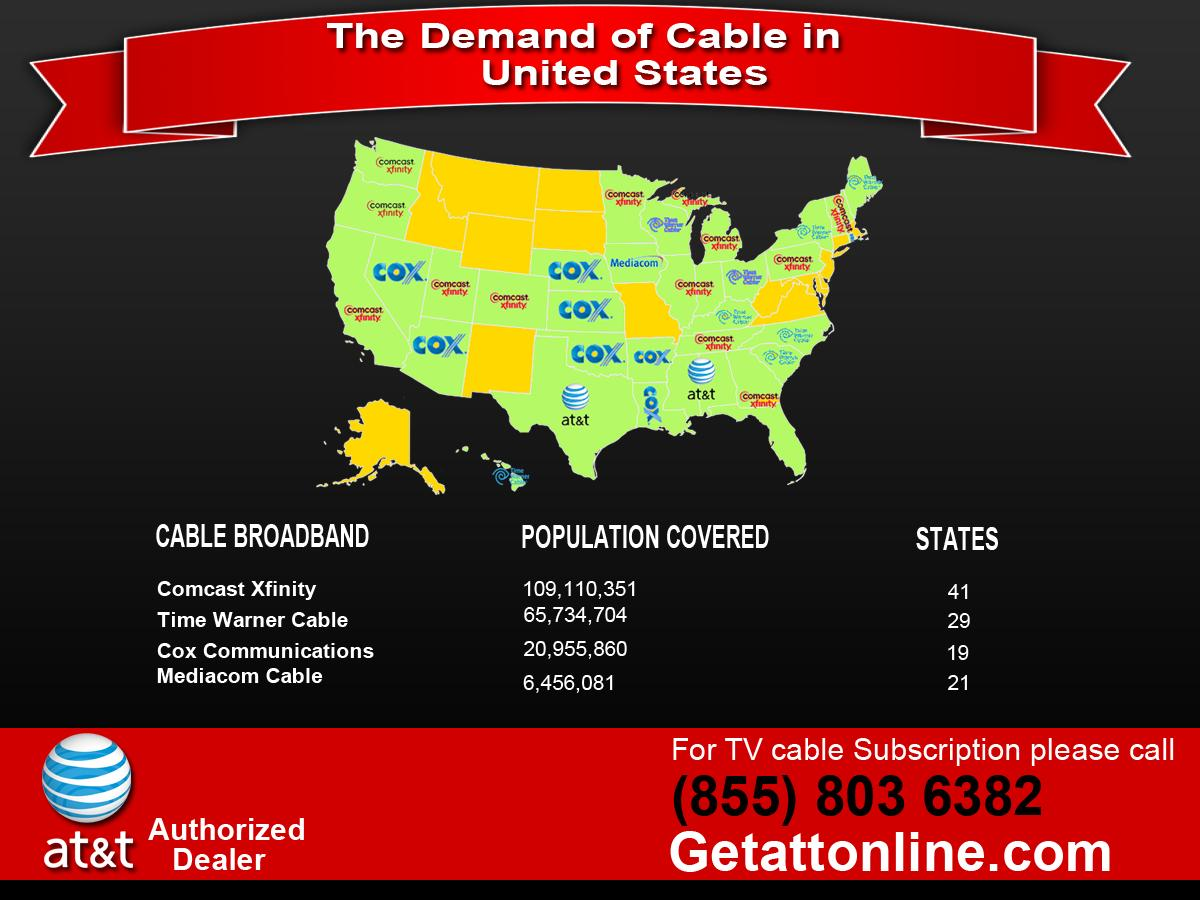Identify some key points in this picture. There are currently five cable broadband providers in the United States. In total, the population covered by the four broadband cable companies excluding AT&T is 202,256,996. According to information available, Comcast Xfinity is the cable broadband provider in 13 states in the United States. Of the states on the map, two have AT&T as their primary cable broadband provider. Seven states have COX Communications as their cable broadband provider. 